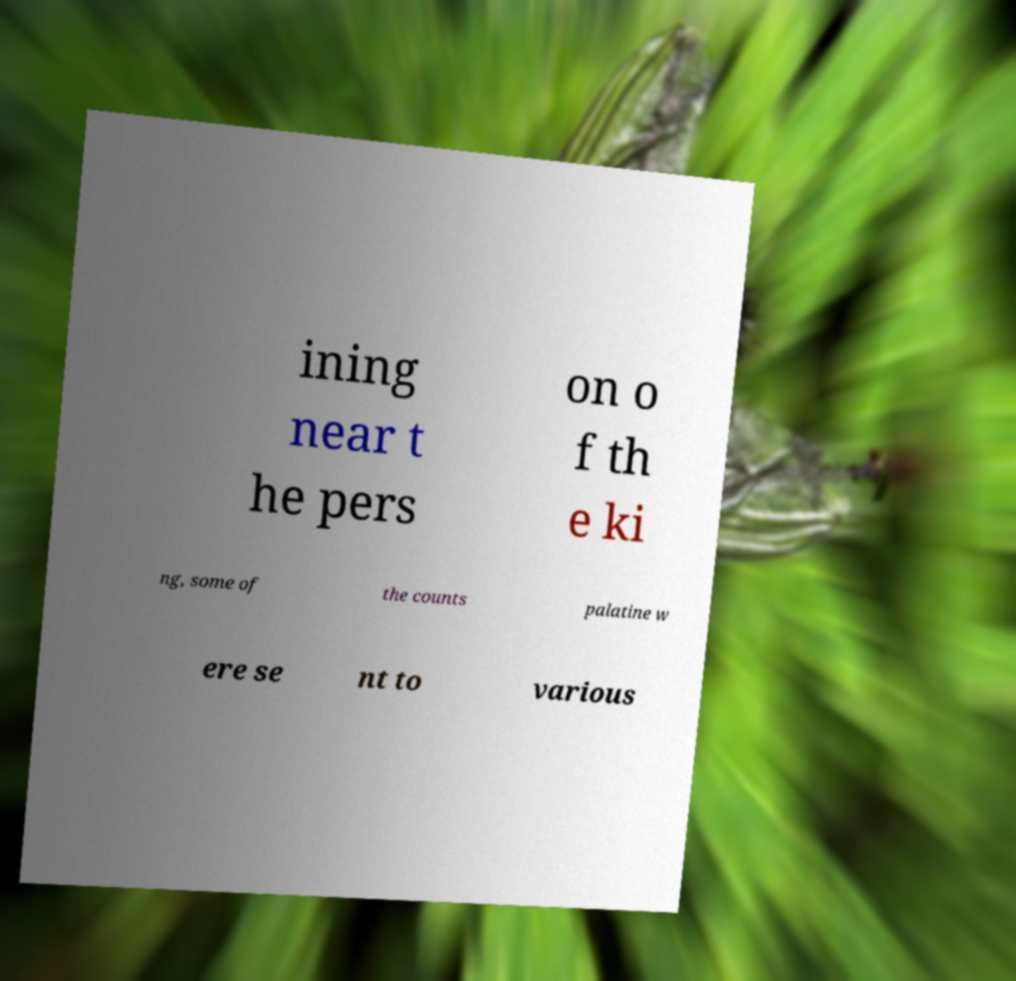For documentation purposes, I need the text within this image transcribed. Could you provide that? ining near t he pers on o f th e ki ng, some of the counts palatine w ere se nt to various 